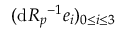<formula> <loc_0><loc_0><loc_500><loc_500>( d R _ { p ^ { - 1 } e _ { i } ) _ { 0 \leq i \leq 3 }</formula> 